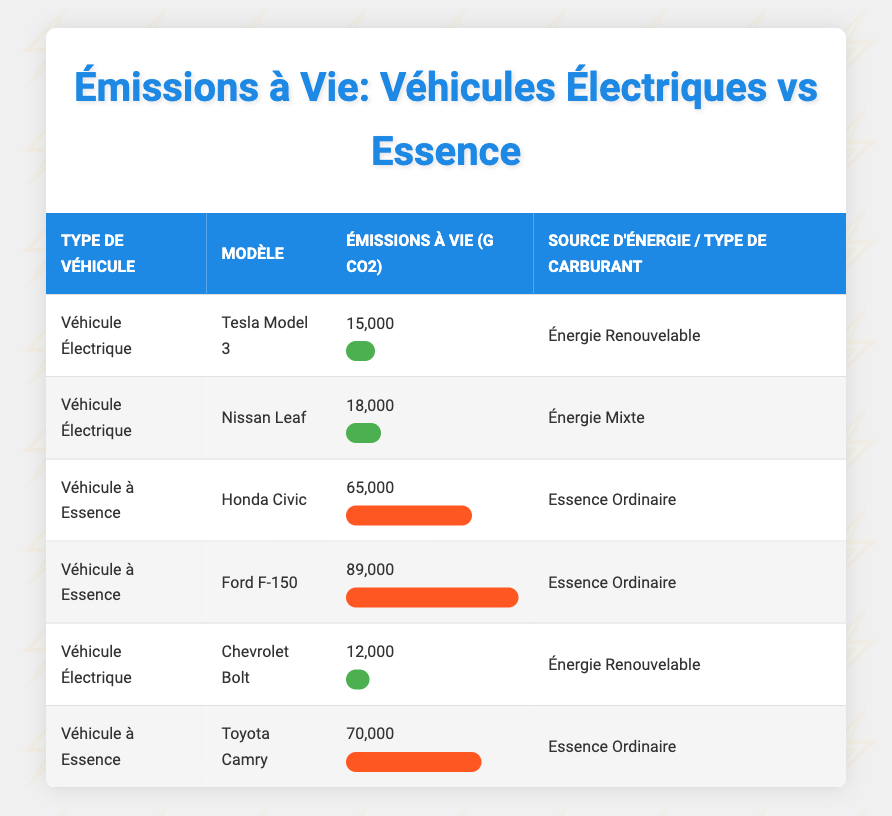What is the lifetime emission of the Tesla Model 3? The table directly lists the Tesla Model 3 under the Electric Vehicle category with a stated lifetime emission of 15,000 grams of CO2.
Answer: 15,000 grams CO2 Which vehicle type shows the lowest lifetime emissions? Comparing all vehicles in the table, the Chevrolet Bolt has the lowest emissions at 12,000 grams of CO2, followed by the Tesla Model 3 at 15,000 grams.
Answer: Electric Vehicle What is the average lifetime emission of gasoline vehicles? The gasoline vehicles listed are the Honda Civic (65,000), Ford F-150 (89,000), and Toyota Camry (70,000). Their total emissions are 65,000 + 89,000 + 70,000 = 224,000 grams. Dividing by 3 gives us 224,000 / 3 = 74,666.67 grams CO2.
Answer: 74,667 grams CO2 Is the lifetime emission of the Nissan Leaf higher than that of the Honda Civic? The Nissan Leaf has lifetime emissions of 18,000 grams CO2, while the Honda Civic has emissions of 65,000 grams CO2. Therefore, the claim that the Nissan Leaf's emissions are higher is false.
Answer: No How much greater are the lifetime emissions of the Ford F-150 compared to the Chevrolet Bolt? The Ford F-150 has lifetime emissions of 89,000 grams CO2, while the Chevrolet Bolt has 12,000 grams CO2. The difference is 89,000 - 12,000 = 77,000 grams CO2.
Answer: 77,000 grams CO2 Do any electric vehicles use regular gasoline as their energy source? The table indicates all electric vehicles (Tesla Model 3, Nissan Leaf, Chevrolet Bolt) utilize various forms of energy, specifically listing Renewable Energy and Mixed Energy, none use regular gasoline.
Answer: No Which electric vehicle has the highest lifetime emissions? The Tesla Model 3, Nissan Leaf, and Chevrolet Bolt have lifetime emissions of 15,000, 18,000, and 12,000 grams CO2 respectively. Thus, the Nissan Leaf has the highest emissions at 18,000 grams CO2.
Answer: Nissan Leaf What percentage of the lifetime emissions of a Ford F-150 is greater than that of a Tesla Model 3? The emissions of the Ford F-150 are 89,000 grams, and the Tesla Model 3 are 15,000 grams. The difference is 89,000 - 15,000 = 74,000 grams. To find the percentage, (74,000 / 15,000) * 100 = 493.33%.
Answer: 493.33% 